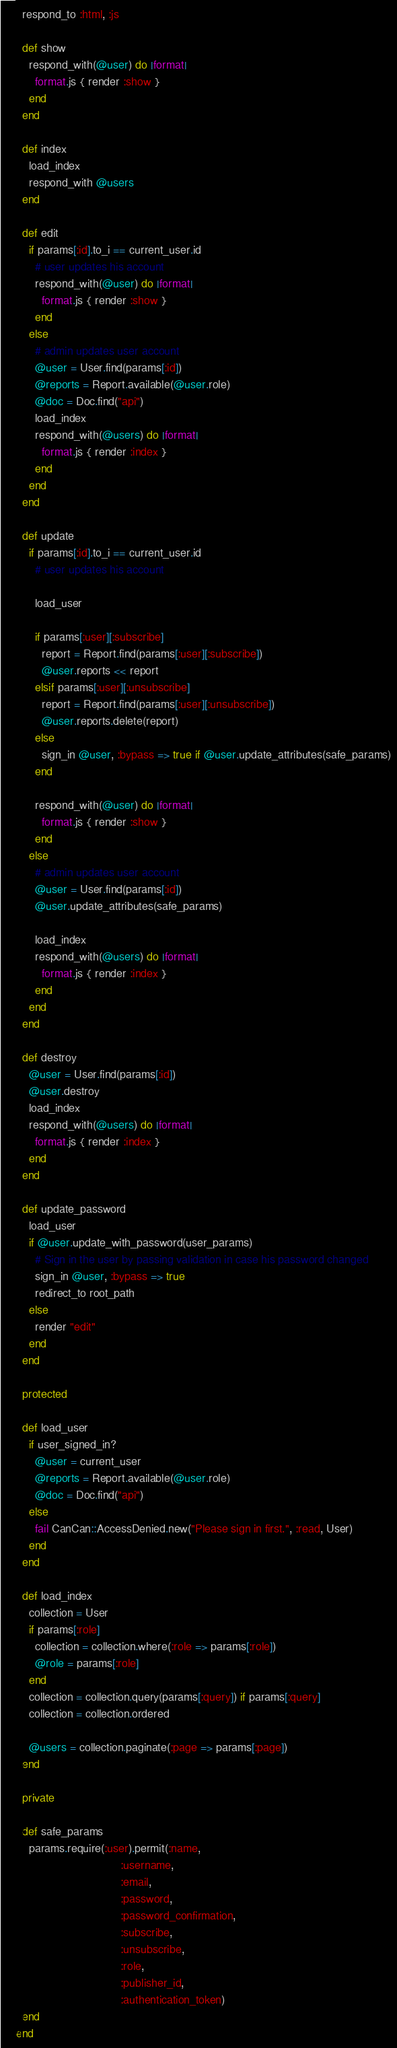<code> <loc_0><loc_0><loc_500><loc_500><_Ruby_>
  respond_to :html, :js

  def show
    respond_with(@user) do |format|
      format.js { render :show }
    end
  end

  def index
    load_index
    respond_with @users
  end

  def edit
    if params[:id].to_i == current_user.id
      # user updates his account
      respond_with(@user) do |format|
        format.js { render :show }
      end
    else
      # admin updates user account
      @user = User.find(params[:id])
      @reports = Report.available(@user.role)
      @doc = Doc.find("api")
      load_index
      respond_with(@users) do |format|
        format.js { render :index }
      end
    end
  end

  def update
    if params[:id].to_i == current_user.id
      # user updates his account

      load_user

      if params[:user][:subscribe]
        report = Report.find(params[:user][:subscribe])
        @user.reports << report
      elsif params[:user][:unsubscribe]
        report = Report.find(params[:user][:unsubscribe])
        @user.reports.delete(report)
      else
        sign_in @user, :bypass => true if @user.update_attributes(safe_params)
      end

      respond_with(@user) do |format|
        format.js { render :show }
      end
    else
      # admin updates user account
      @user = User.find(params[:id])
      @user.update_attributes(safe_params)

      load_index
      respond_with(@users) do |format|
        format.js { render :index }
      end
    end
  end

  def destroy
    @user = User.find(params[:id])
    @user.destroy
    load_index
    respond_with(@users) do |format|
      format.js { render :index }
    end
  end

  def update_password
    load_user
    if @user.update_with_password(user_params)
      # Sign in the user by passing validation in case his password changed
      sign_in @user, :bypass => true
      redirect_to root_path
    else
      render "edit"
    end
  end

  protected

  def load_user
    if user_signed_in?
      @user = current_user
      @reports = Report.available(@user.role)
      @doc = Doc.find("api")
    else
      fail CanCan::AccessDenied.new("Please sign in first.", :read, User)
    end
  end

  def load_index
    collection = User
    if params[:role]
      collection = collection.where(:role => params[:role])
      @role = params[:role]
    end
    collection = collection.query(params[:query]) if params[:query]
    collection = collection.ordered

    @users = collection.paginate(:page => params[:page])
  end

  private

  def safe_params
    params.require(:user).permit(:name,
                                 :username,
                                 :email,
                                 :password,
                                 :password_confirmation,
                                 :subscribe,
                                 :unsubscribe,
                                 :role,
                                 :publisher_id,
                                 :authentication_token)
  end
end
</code> 